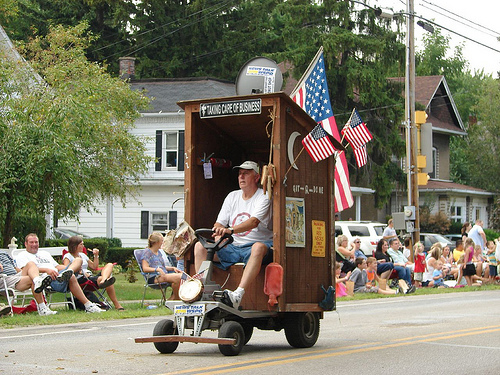<image>
Is the man on the porta potty? Yes. Looking at the image, I can see the man is positioned on top of the porta potty, with the porta potty providing support. 